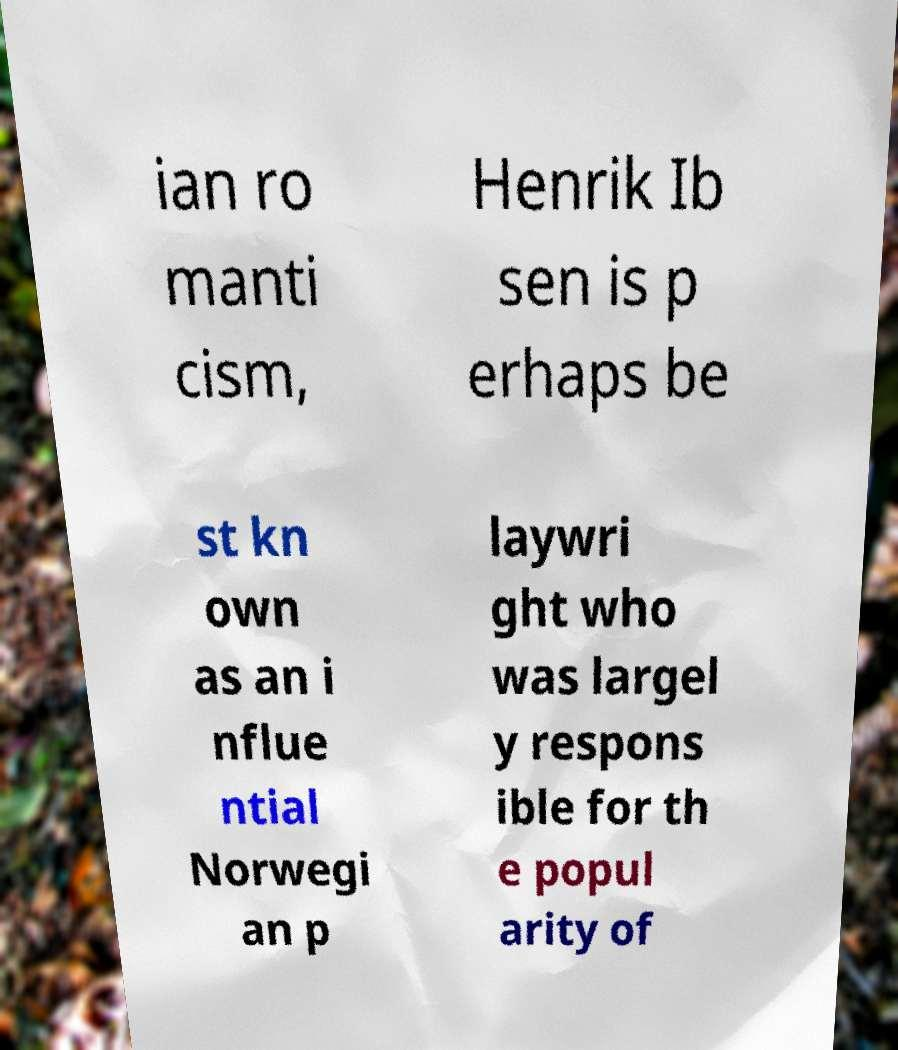Can you accurately transcribe the text from the provided image for me? ian ro manti cism, Henrik Ib sen is p erhaps be st kn own as an i nflue ntial Norwegi an p laywri ght who was largel y respons ible for th e popul arity of 